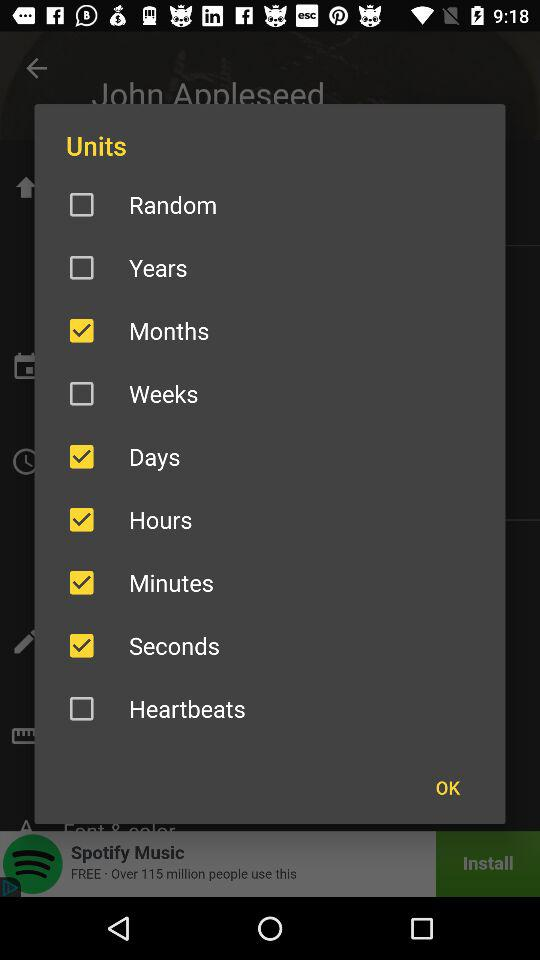What is the status of "Months"? The status of "Months" is "on". 